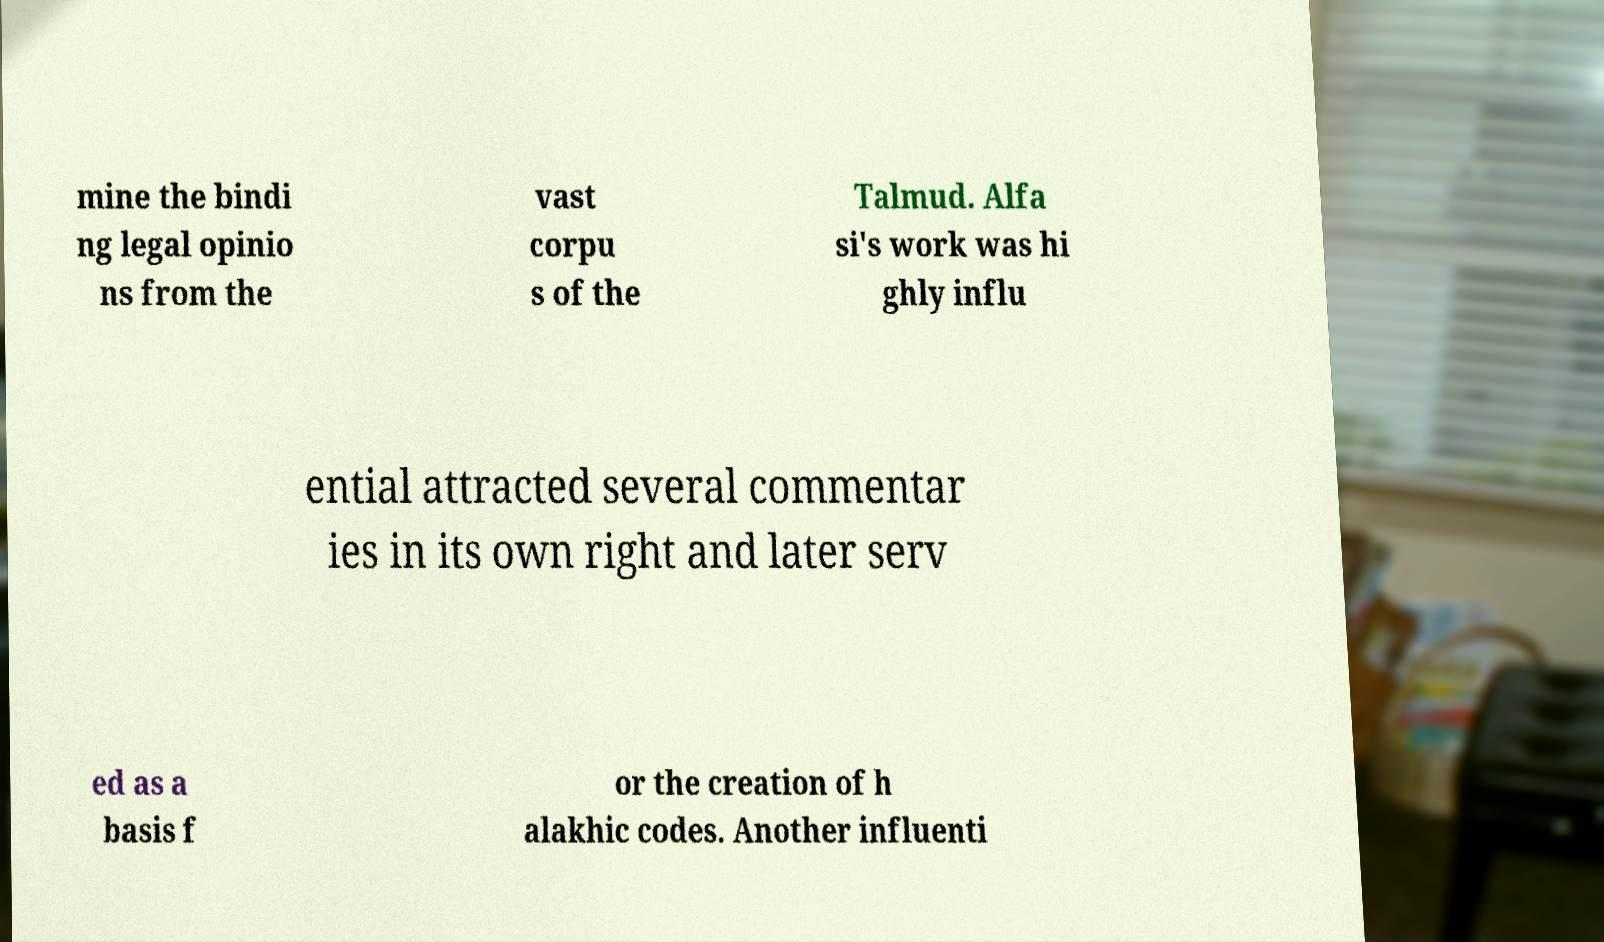For documentation purposes, I need the text within this image transcribed. Could you provide that? mine the bindi ng legal opinio ns from the vast corpu s of the Talmud. Alfa si's work was hi ghly influ ential attracted several commentar ies in its own right and later serv ed as a basis f or the creation of h alakhic codes. Another influenti 